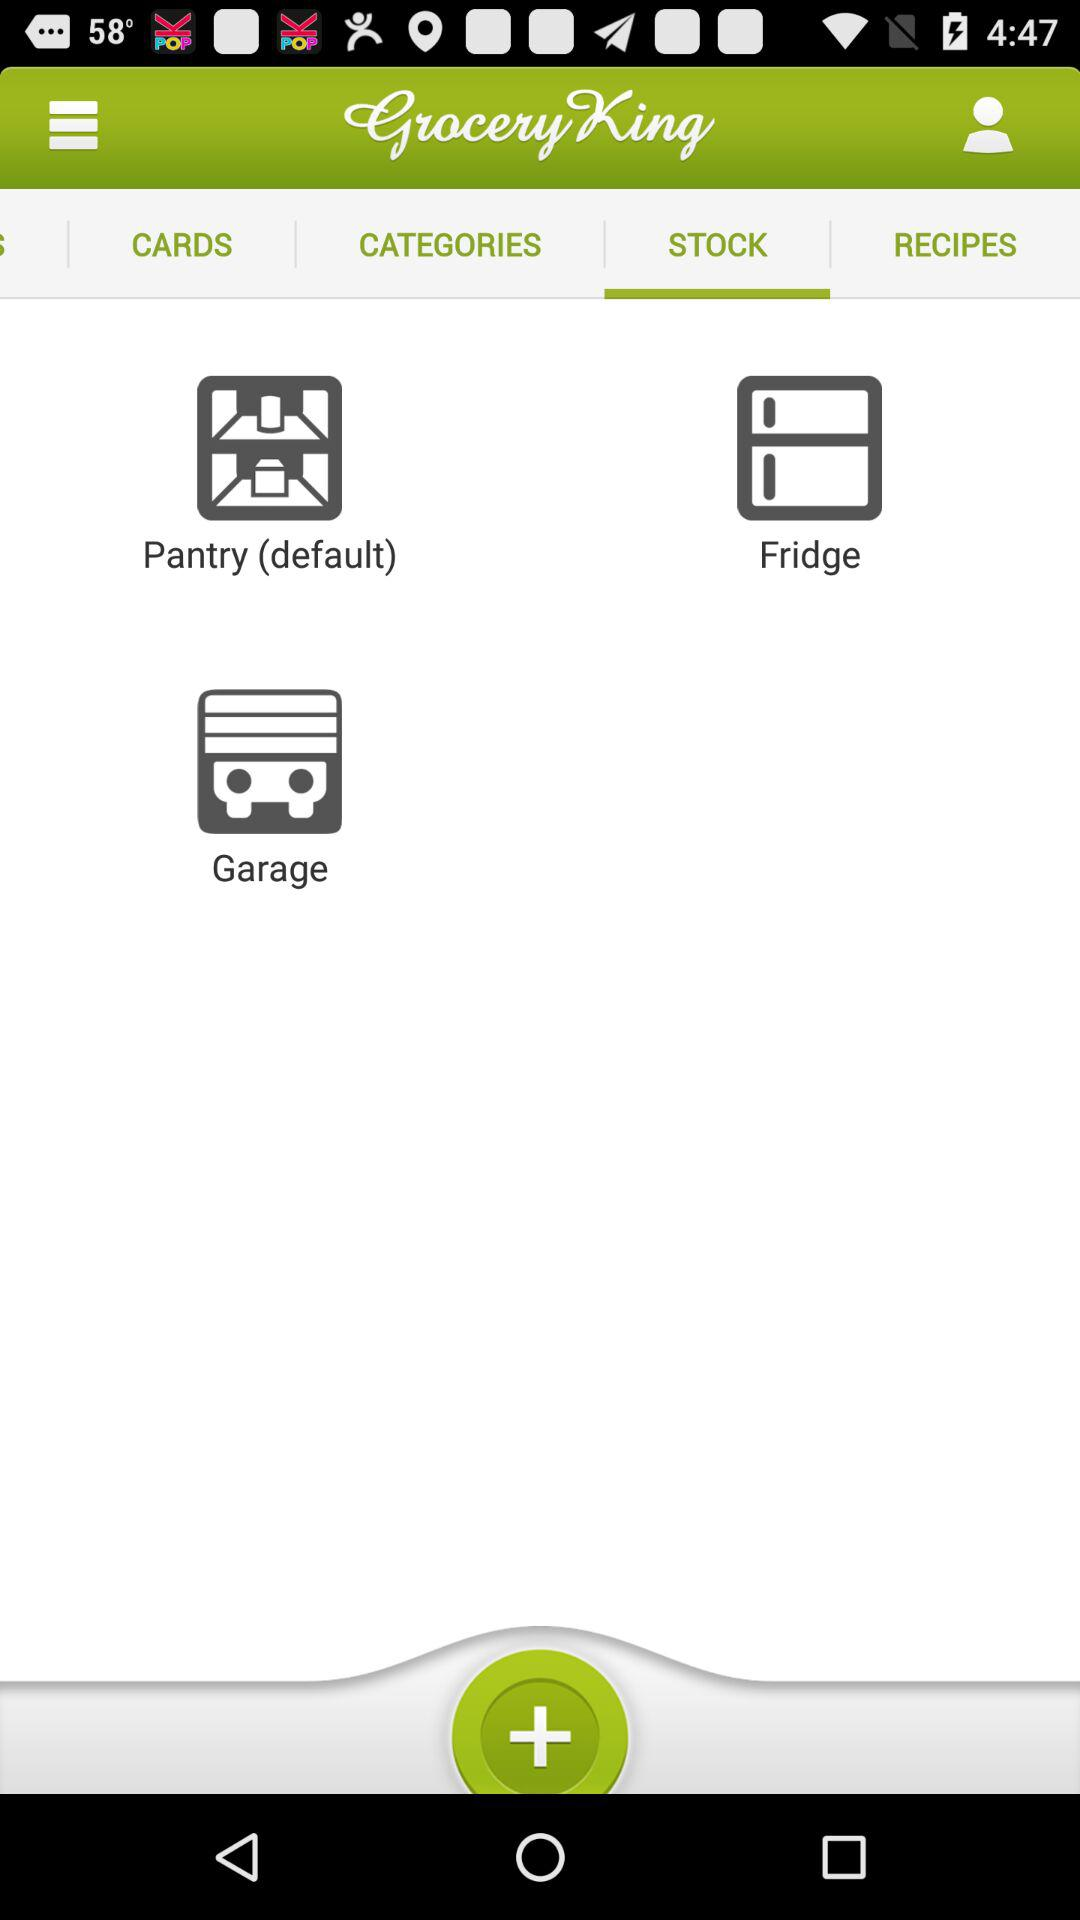What is the name of the application? The name of the application is "Grocery King". 